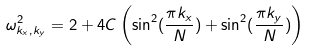Convert formula to latex. <formula><loc_0><loc_0><loc_500><loc_500>\omega ^ { 2 } _ { k _ { x } , k _ { y } } = 2 + 4 C \left ( \sin ^ { 2 } ( \frac { \pi k _ { x } } { N } ) + \sin ^ { 2 } ( \frac { \pi k _ { y } } { N } ) \right )</formula> 